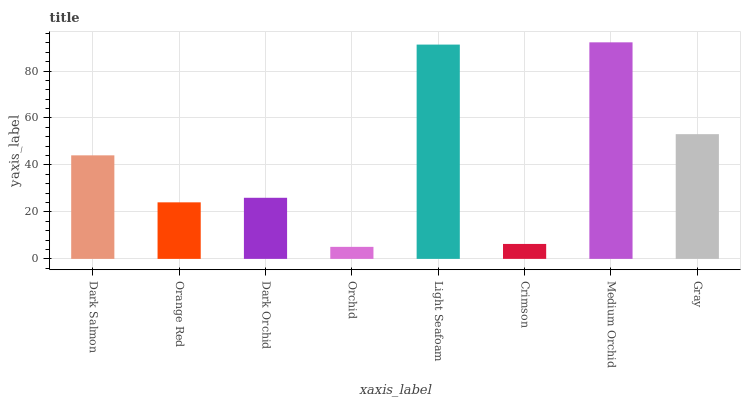Is Orchid the minimum?
Answer yes or no. Yes. Is Medium Orchid the maximum?
Answer yes or no. Yes. Is Orange Red the minimum?
Answer yes or no. No. Is Orange Red the maximum?
Answer yes or no. No. Is Dark Salmon greater than Orange Red?
Answer yes or no. Yes. Is Orange Red less than Dark Salmon?
Answer yes or no. Yes. Is Orange Red greater than Dark Salmon?
Answer yes or no. No. Is Dark Salmon less than Orange Red?
Answer yes or no. No. Is Dark Salmon the high median?
Answer yes or no. Yes. Is Dark Orchid the low median?
Answer yes or no. Yes. Is Dark Orchid the high median?
Answer yes or no. No. Is Orchid the low median?
Answer yes or no. No. 